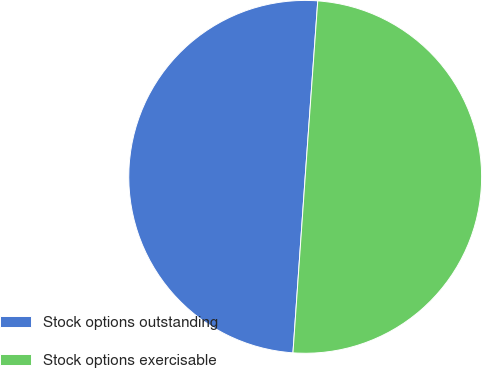<chart> <loc_0><loc_0><loc_500><loc_500><pie_chart><fcel>Stock options outstanding<fcel>Stock options exercisable<nl><fcel>50.03%<fcel>49.97%<nl></chart> 